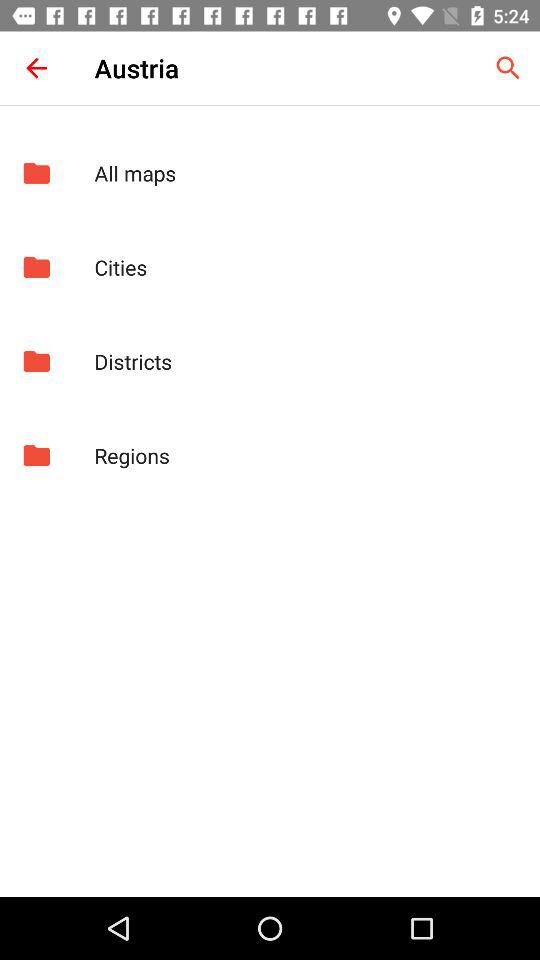What are the different folders? The different folders are "All maps", "Cities", "Districts" and "Regions". 